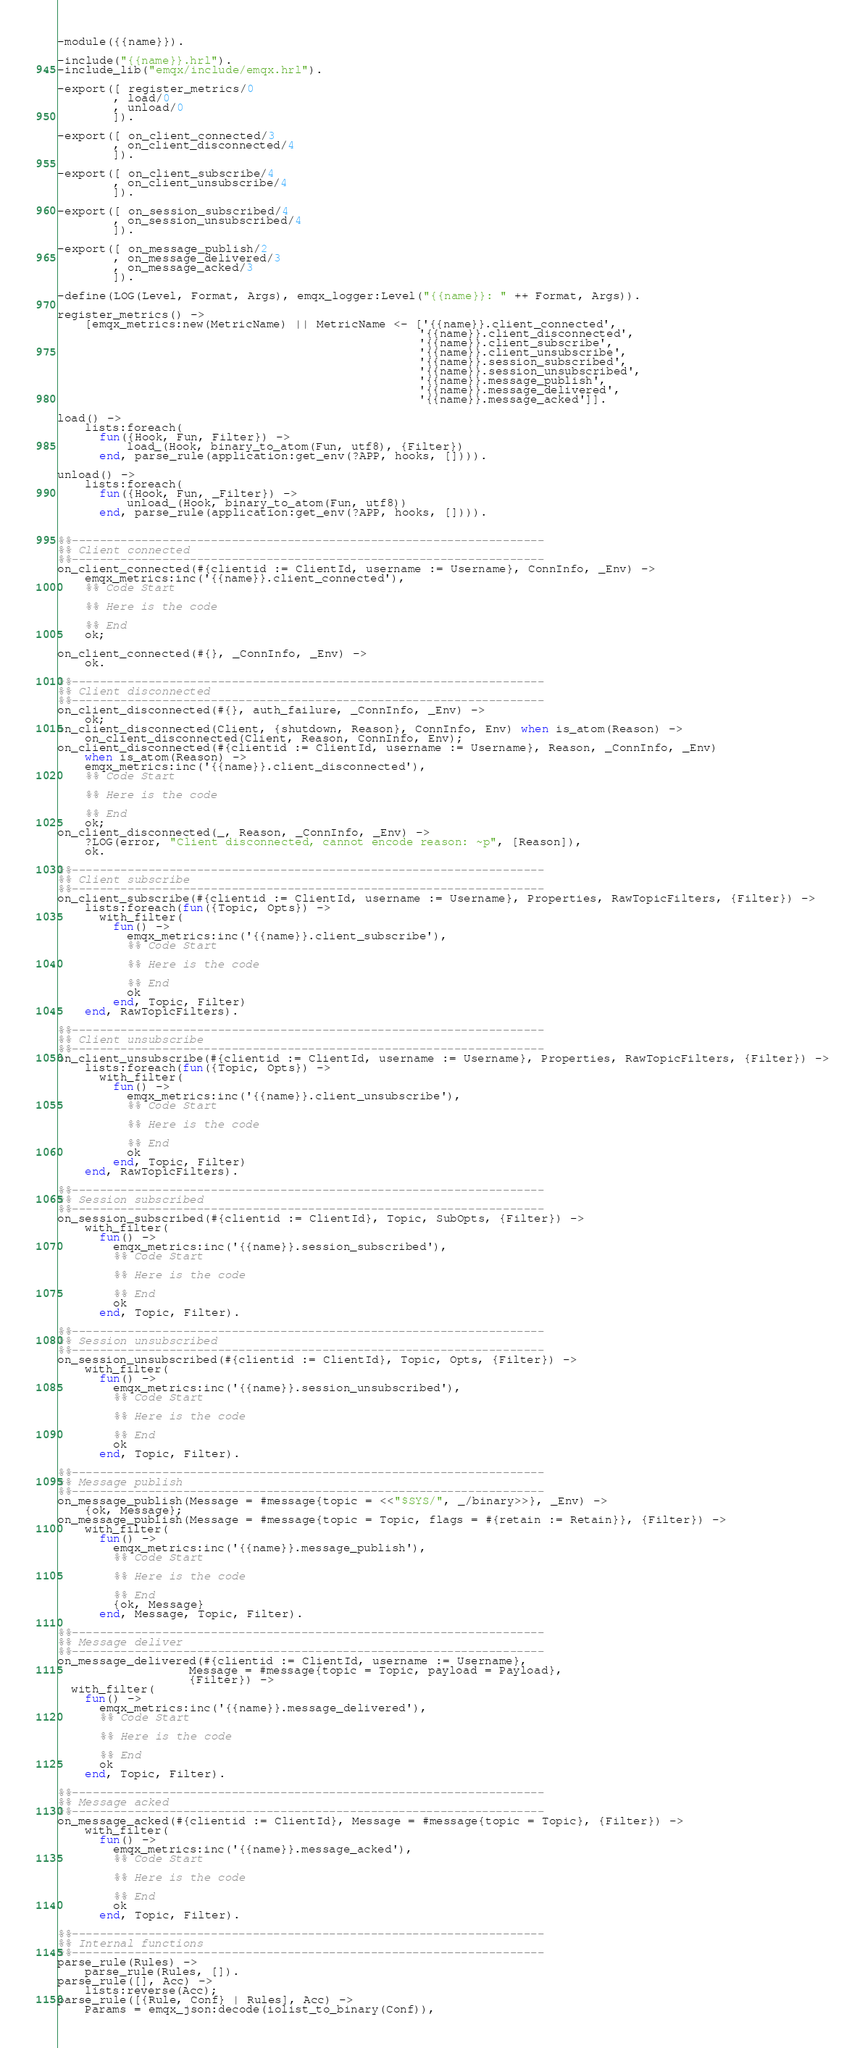<code> <loc_0><loc_0><loc_500><loc_500><_Erlang_>-module({{name}}).

-include("{{name}}.hrl").
-include_lib("emqx/include/emqx.hrl").

-export([ register_metrics/0
        , load/0
        , unload/0
        ]).

-export([ on_client_connected/3
        , on_client_disconnected/4
        ]).

-export([ on_client_subscribe/4
        , on_client_unsubscribe/4
        ]).

-export([ on_session_subscribed/4
        , on_session_unsubscribed/4
        ]).

-export([ on_message_publish/2
        , on_message_delivered/3
        , on_message_acked/3
        ]).

-define(LOG(Level, Format, Args), emqx_logger:Level("{{name}}: " ++ Format, Args)).

register_metrics() ->
    [emqx_metrics:new(MetricName) || MetricName <- ['{{name}}.client_connected',
                                                    '{{name}}.client_disconnected',
                                                    '{{name}}.client_subscribe',
                                                    '{{name}}.client_unsubscribe',
                                                    '{{name}}.session_subscribed',
                                                    '{{name}}.session_unsubscribed',
                                                    '{{name}}.message_publish',
                                                    '{{name}}.message_delivered',
                                                    '{{name}}.message_acked']].

load() ->
    lists:foreach(
      fun({Hook, Fun, Filter}) ->
          load_(Hook, binary_to_atom(Fun, utf8), {Filter})
      end, parse_rule(application:get_env(?APP, hooks, []))).

unload() ->
    lists:foreach(
      fun({Hook, Fun, _Filter}) ->
          unload_(Hook, binary_to_atom(Fun, utf8))
      end, parse_rule(application:get_env(?APP, hooks, []))).


%%--------------------------------------------------------------------
%% Client connected
%%--------------------------------------------------------------------
on_client_connected(#{clientid := ClientId, username := Username}, ConnInfo, _Env) ->
    emqx_metrics:inc('{{name}}.client_connected'),
    %% Code Start

    %% Here is the code

    %% End
    ok;

on_client_connected(#{}, _ConnInfo, _Env) ->
    ok.

%%--------------------------------------------------------------------
%% Client disconnected
%%--------------------------------------------------------------------
on_client_disconnected(#{}, auth_failure, _ConnInfo, _Env) ->
    ok;
on_client_disconnected(Client, {shutdown, Reason}, ConnInfo, Env) when is_atom(Reason) ->
    on_client_disconnected(Client, Reason, ConnInfo, Env);
on_client_disconnected(#{clientid := ClientId, username := Username}, Reason, _ConnInfo, _Env)
    when is_atom(Reason) ->
    emqx_metrics:inc('{{name}}.client_disconnected'),
    %% Code Start

    %% Here is the code

    %% End
    ok;
on_client_disconnected(_, Reason, _ConnInfo, _Env) ->
    ?LOG(error, "Client disconnected, cannot encode reason: ~p", [Reason]),
    ok.

%%--------------------------------------------------------------------
%% Client subscribe
%%--------------------------------------------------------------------
on_client_subscribe(#{clientid := ClientId, username := Username}, Properties, RawTopicFilters, {Filter}) ->
    lists:foreach(fun({Topic, Opts}) ->
      with_filter(
        fun() ->
          emqx_metrics:inc('{{name}}.client_subscribe'),
          %% Code Start

          %% Here is the code

          %% End
          ok
        end, Topic, Filter)
    end, RawTopicFilters).

%%--------------------------------------------------------------------
%% Client unsubscribe
%%--------------------------------------------------------------------
on_client_unsubscribe(#{clientid := ClientId, username := Username}, Properties, RawTopicFilters, {Filter}) ->
    lists:foreach(fun({Topic, Opts}) ->
      with_filter(
        fun() ->
          emqx_metrics:inc('{{name}}.client_unsubscribe'),
          %% Code Start

          %% Here is the code

          %% End
          ok
        end, Topic, Filter)
    end, RawTopicFilters).

%%--------------------------------------------------------------------
%% Session subscribed
%%--------------------------------------------------------------------
on_session_subscribed(#{clientid := ClientId}, Topic, SubOpts, {Filter}) ->
    with_filter(
      fun() ->
        emqx_metrics:inc('{{name}}.session_subscribed'),
        %% Code Start

        %% Here is the code

        %% End
        ok
      end, Topic, Filter).

%%--------------------------------------------------------------------
%% Session unsubscribed
%%--------------------------------------------------------------------
on_session_unsubscribed(#{clientid := ClientId}, Topic, Opts, {Filter}) ->
    with_filter(
      fun() ->
        emqx_metrics:inc('{{name}}.session_unsubscribed'),
        %% Code Start

        %% Here is the code

        %% End
        ok
      end, Topic, Filter).

%%--------------------------------------------------------------------
%% Message publish
%%--------------------------------------------------------------------
on_message_publish(Message = #message{topic = <<"$SYS/", _/binary>>}, _Env) ->
    {ok, Message};
on_message_publish(Message = #message{topic = Topic, flags = #{retain := Retain}}, {Filter}) ->
    with_filter(
      fun() ->
        emqx_metrics:inc('{{name}}.message_publish'),
        %% Code Start

        %% Here is the code

        %% End
        {ok, Message}
      end, Message, Topic, Filter).

%%--------------------------------------------------------------------
%% Message deliver
%%--------------------------------------------------------------------
on_message_delivered(#{clientid := ClientId, username := Username},
                   Message = #message{topic = Topic, payload = Payload},
                   {Filter}) ->
  with_filter(
    fun() ->
      emqx_metrics:inc('{{name}}.message_delivered'),
      %% Code Start

      %% Here is the code

      %% End
      ok
    end, Topic, Filter).

%%--------------------------------------------------------------------
%% Message acked
%%--------------------------------------------------------------------
on_message_acked(#{clientid := ClientId}, Message = #message{topic = Topic}, {Filter}) ->
    with_filter(
      fun() ->
        emqx_metrics:inc('{{name}}.message_acked'),
        %% Code Start

        %% Here is the code

        %% End
        ok
      end, Topic, Filter).

%%--------------------------------------------------------------------
%% Internal functions
%%--------------------------------------------------------------------
parse_rule(Rules) ->
    parse_rule(Rules, []).
parse_rule([], Acc) ->
    lists:reverse(Acc);
parse_rule([{Rule, Conf} | Rules], Acc) ->
    Params = emqx_json:decode(iolist_to_binary(Conf)),</code> 